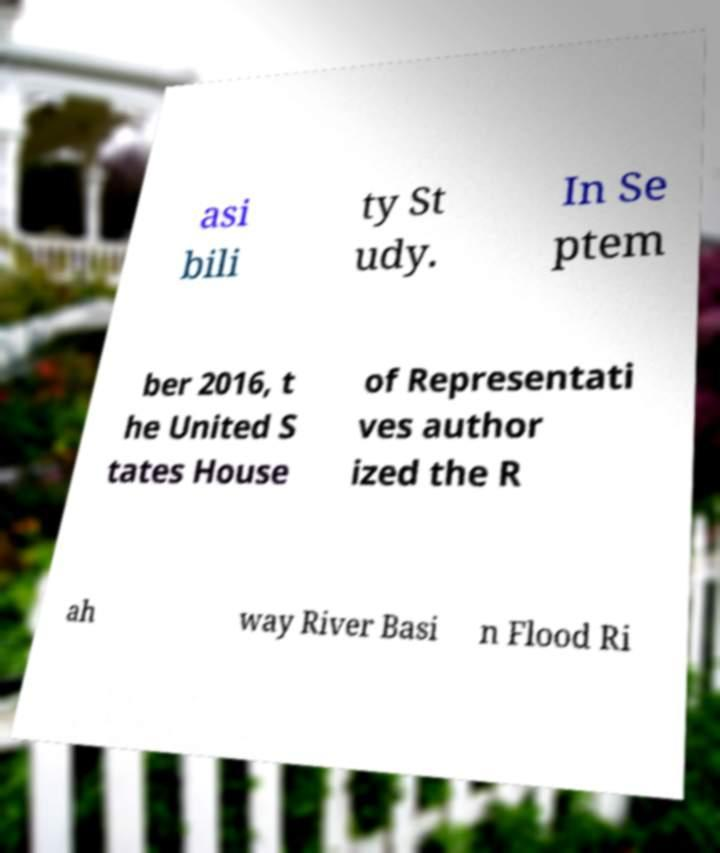Can you accurately transcribe the text from the provided image for me? asi bili ty St udy. In Se ptem ber 2016, t he United S tates House of Representati ves author ized the R ah way River Basi n Flood Ri 